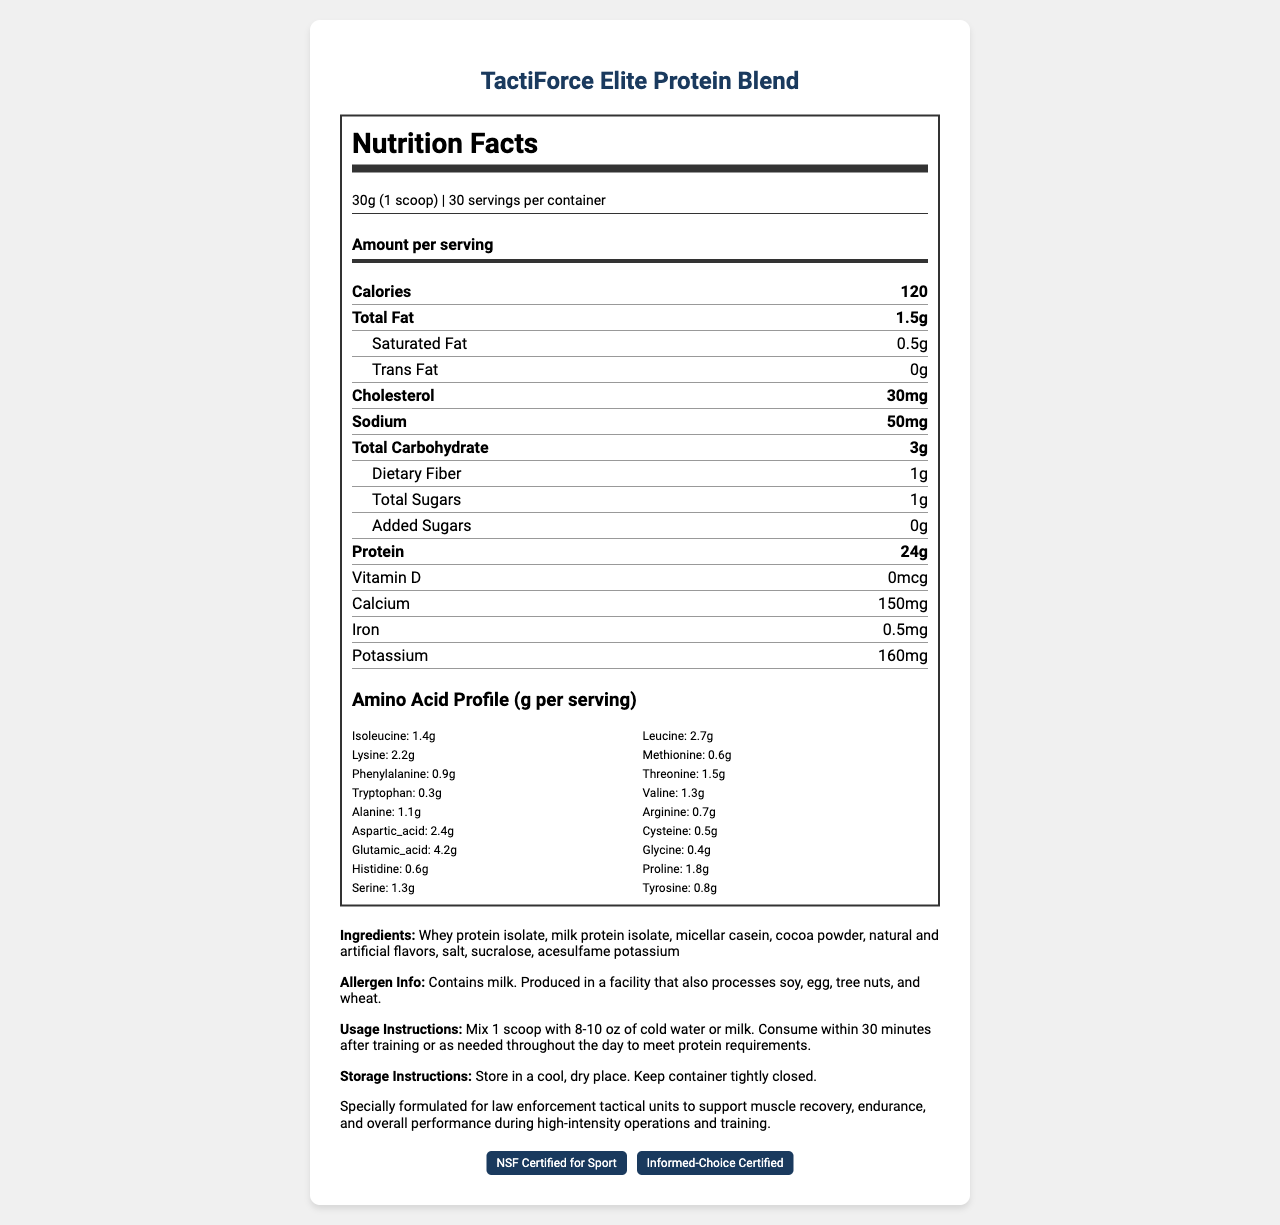what is the serving size? The serving size is stated at the beginning of the Nutrition Facts section.
Answer: 30g (1 scoop) how many servings are there per container? The document specifies that there are 30 servings per container.
Answer: 30 how many grams of protein are in one serving? The amount of protein per serving is displayed in the Nutrition Facts section.
Answer: 24g what is the total fat per serving? The total fat content per serving is listed under the Nutrition Facts section.
Answer: 1.5g what percentage of the product is made up of leucine per serving? The product’s amino acid profile shows 2.7g of leucine per serving size of 30g, meaning leucine constitutes roughly 9% of each serving.
Answer: 2.7g / 30g which vitamin or mineral is present in the highest amount per serving? A. Calcium B. Iron C. Potassium According to the document, calcium is present at 150mg per serving, which is higher than iron (0.5mg) and potassium (160mg).
Answer: A. Calcium how much sodium does one serving contain? A. 30mg B. 50mg C. 100mg The sodium content per serving is listed as 50mg in the Nutrition Facts section.
Answer: B. 50mg does the product contain any added sugars? The document states that the product contains 0g of added sugars.
Answer: No is the product free from any allergens? The allergen info section states that the product contains milk and is produced in a facility that also processes soy, egg, tree nuts, and wheat.
Answer: No what certifications does the product hold? The certifications listed at the bottom of the document include NSF Certified for Sport and Informed-Choice Certified.
Answer: NSF Certified for Sport, Informed-Choice Certified briefly summarize the main idea of the document. The document showcases detailed nutritional and usage information for TactiForce Elite Protein Blend, emphasizing its suitability for high-intensity operations through its amino acid content and endorsed certifications.
Answer: The document provides detailed nutritional information about TactiForce Elite Protein Blend, including serving size, nutritional content, amino acid profile, ingredients, allergen information, usage, and storage instructions. The product is designed to aid muscle recovery, endurance, and overall performance for law enforcement tactical units. what is the ratio of alanine to proline in one serving? Alanine and proline amounts are provided in the amino acid profile section.
Answer: 1.1g: 1.8g how should the product be stored and used? The storage and usage instructions are clearly stated in the document.
Answer: Store in a cool, dry place, and mix 1 scoop with cold water or milk, to be consumed within 30 minutes after training or as needed. what is the primary ingredient in the product? The ingredients list starts with whey protein isolate, indicating it is the primary ingredient.
Answer: Whey protein isolate does the nutritional label indicate if the product aids endurance? The additional info section explicitly states it is formulated to support endurance during high-intensity operations and training.
Answer: Yes what is the percentage of iron per serving? The specific daily value percentages are not provided in the document.
Answer: Cannot be determined 